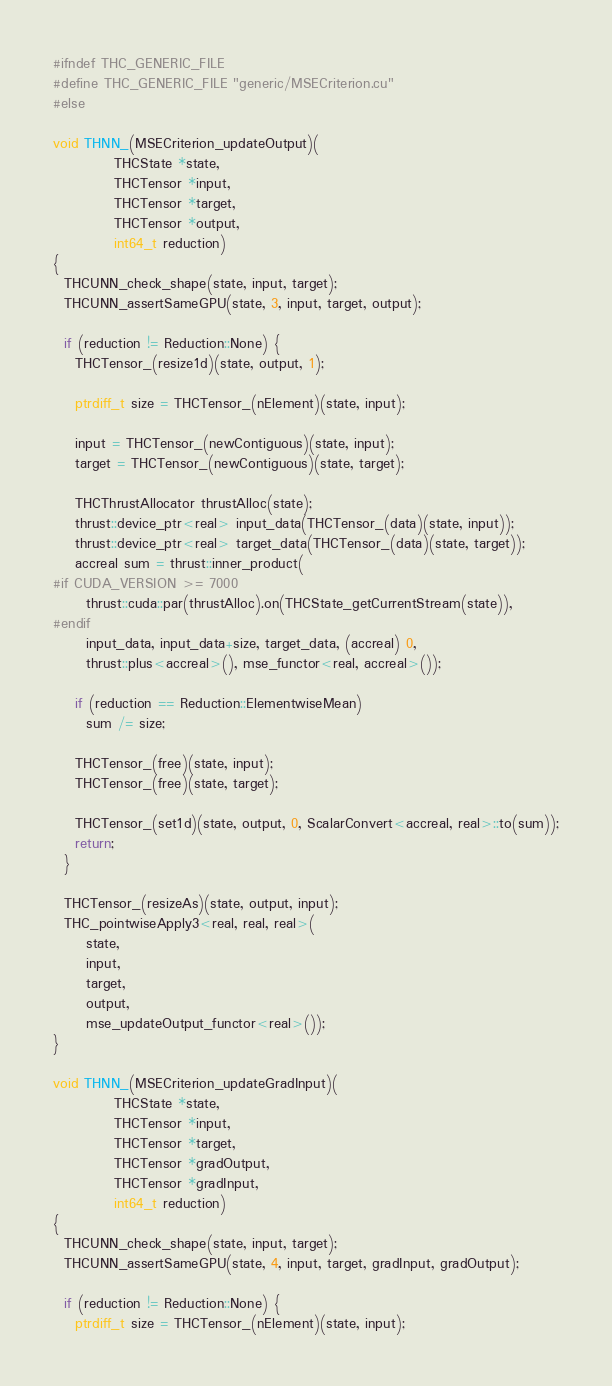Convert code to text. <code><loc_0><loc_0><loc_500><loc_500><_Cuda_>#ifndef THC_GENERIC_FILE
#define THC_GENERIC_FILE "generic/MSECriterion.cu"
#else

void THNN_(MSECriterion_updateOutput)(
           THCState *state,
           THCTensor *input,
           THCTensor *target,
           THCTensor *output,
           int64_t reduction)
{
  THCUNN_check_shape(state, input, target);
  THCUNN_assertSameGPU(state, 3, input, target, output);

  if (reduction != Reduction::None) {
    THCTensor_(resize1d)(state, output, 1);

    ptrdiff_t size = THCTensor_(nElement)(state, input);

    input = THCTensor_(newContiguous)(state, input);
    target = THCTensor_(newContiguous)(state, target);

    THCThrustAllocator thrustAlloc(state);
    thrust::device_ptr<real> input_data(THCTensor_(data)(state, input));
    thrust::device_ptr<real> target_data(THCTensor_(data)(state, target));
    accreal sum = thrust::inner_product(
#if CUDA_VERSION >= 7000
      thrust::cuda::par(thrustAlloc).on(THCState_getCurrentStream(state)),
#endif
      input_data, input_data+size, target_data, (accreal) 0,
      thrust::plus<accreal>(), mse_functor<real, accreal>());

    if (reduction == Reduction::ElementwiseMean)
      sum /= size;

    THCTensor_(free)(state, input);
    THCTensor_(free)(state, target);

    THCTensor_(set1d)(state, output, 0, ScalarConvert<accreal, real>::to(sum));
    return;
  }

  THCTensor_(resizeAs)(state, output, input);
  THC_pointwiseApply3<real, real, real>(
      state,
      input,
      target,
      output,
      mse_updateOutput_functor<real>());
}

void THNN_(MSECriterion_updateGradInput)(
           THCState *state,
           THCTensor *input,
           THCTensor *target,
           THCTensor *gradOutput,
           THCTensor *gradInput,
           int64_t reduction)
{
  THCUNN_check_shape(state, input, target);
  THCUNN_assertSameGPU(state, 4, input, target, gradInput, gradOutput);

  if (reduction != Reduction::None) {
    ptrdiff_t size = THCTensor_(nElement)(state, input);
</code> 